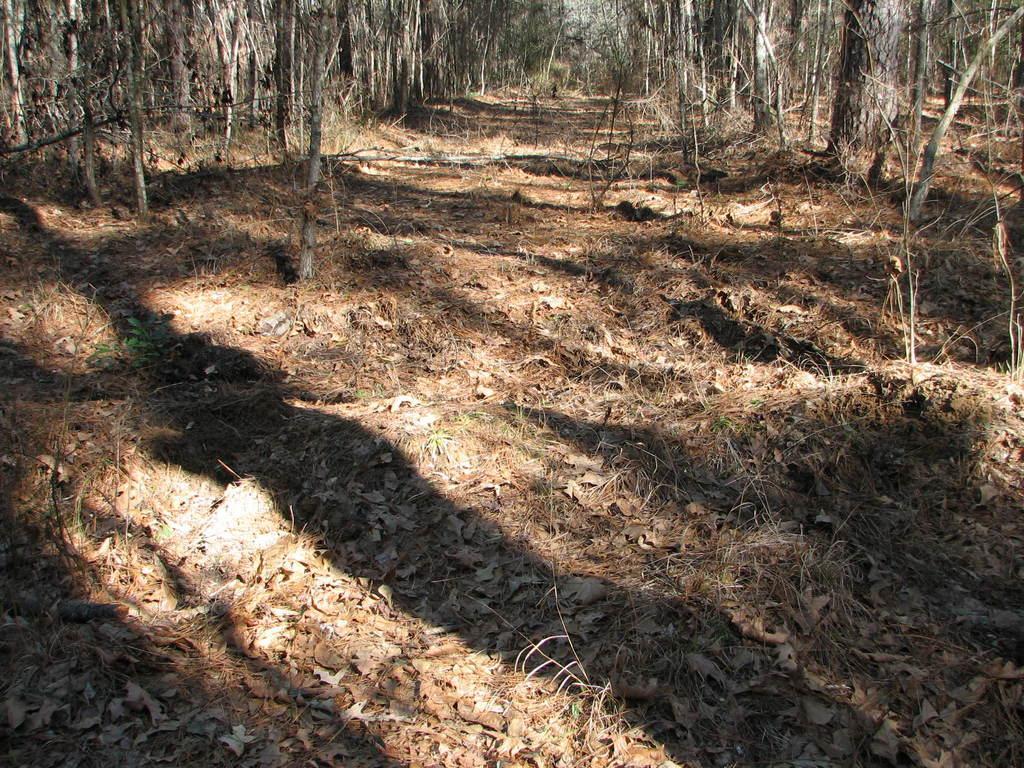In one or two sentences, can you explain what this image depicts? This is a forest area. We can see dried leaves on the ground. We can see trees and tree trunks. 